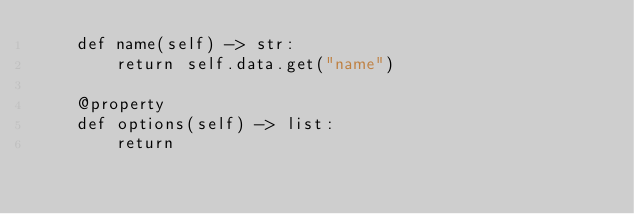<code> <loc_0><loc_0><loc_500><loc_500><_Python_>    def name(self) -> str:
        return self.data.get("name")
    
    @property
    def options(self) -> list:
        return
</code> 